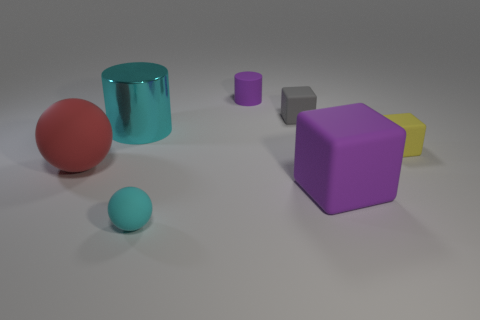Do the tiny purple cylinder and the large purple thing that is behind the tiny cyan rubber object have the same material?
Keep it short and to the point. Yes. There is a yellow object that is made of the same material as the gray cube; what size is it?
Your answer should be very brief. Small. What is the size of the purple matte thing in front of the purple matte cylinder?
Make the answer very short. Large. How many other rubber objects have the same size as the yellow rubber thing?
Ensure brevity in your answer.  3. What size is the object that is the same color as the large cylinder?
Keep it short and to the point. Small. Is there a large cylinder that has the same color as the big rubber ball?
Give a very brief answer. No. There is a rubber cylinder that is the same size as the cyan rubber thing; what color is it?
Your response must be concise. Purple. Does the tiny sphere have the same color as the rubber ball that is on the left side of the tiny cyan rubber object?
Offer a very short reply. No. What color is the matte cylinder?
Offer a very short reply. Purple. What is the sphere that is on the right side of the big cyan object made of?
Provide a succinct answer. Rubber. 